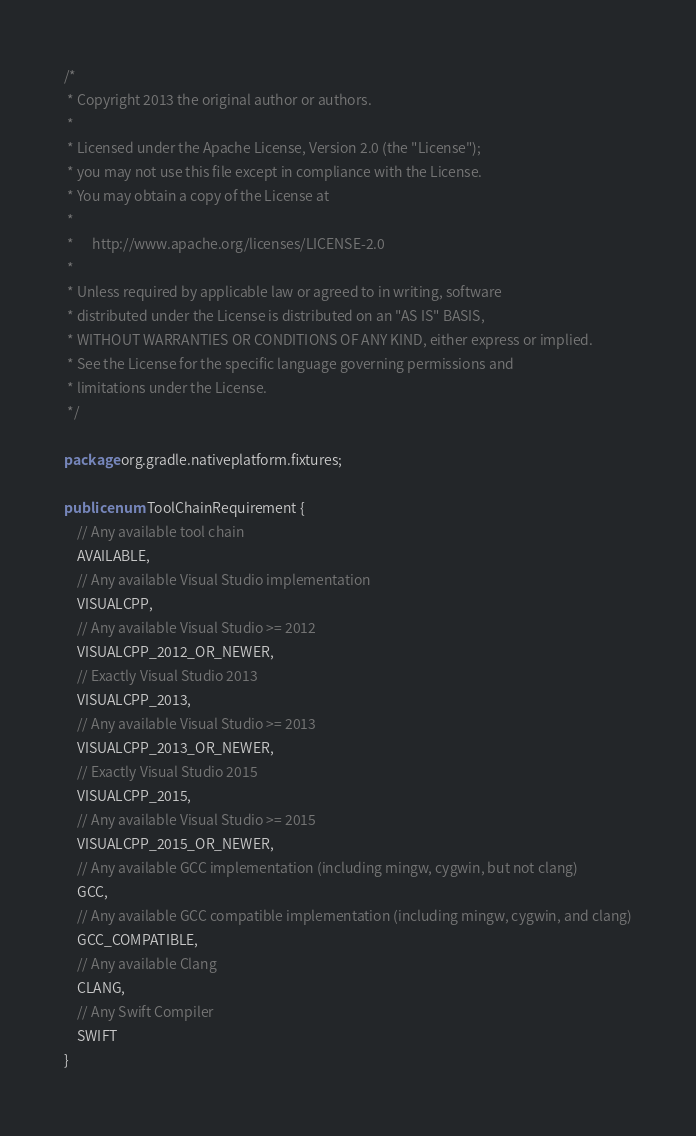Convert code to text. <code><loc_0><loc_0><loc_500><loc_500><_Java_>/*
 * Copyright 2013 the original author or authors.
 *
 * Licensed under the Apache License, Version 2.0 (the "License");
 * you may not use this file except in compliance with the License.
 * You may obtain a copy of the License at
 *
 *      http://www.apache.org/licenses/LICENSE-2.0
 *
 * Unless required by applicable law or agreed to in writing, software
 * distributed under the License is distributed on an "AS IS" BASIS,
 * WITHOUT WARRANTIES OR CONDITIONS OF ANY KIND, either express or implied.
 * See the License for the specific language governing permissions and
 * limitations under the License.
 */

package org.gradle.nativeplatform.fixtures;

public enum ToolChainRequirement {
    // Any available tool chain
    AVAILABLE,
    // Any available Visual Studio implementation
    VISUALCPP,
    // Any available Visual Studio >= 2012
    VISUALCPP_2012_OR_NEWER,
    // Exactly Visual Studio 2013
    VISUALCPP_2013,
    // Any available Visual Studio >= 2013
    VISUALCPP_2013_OR_NEWER,
    // Exactly Visual Studio 2015
    VISUALCPP_2015,
    // Any available Visual Studio >= 2015
    VISUALCPP_2015_OR_NEWER,
    // Any available GCC implementation (including mingw, cygwin, but not clang)
    GCC,
    // Any available GCC compatible implementation (including mingw, cygwin, and clang)
    GCC_COMPATIBLE,
    // Any available Clang
    CLANG,
    // Any Swift Compiler
    SWIFT
}
</code> 